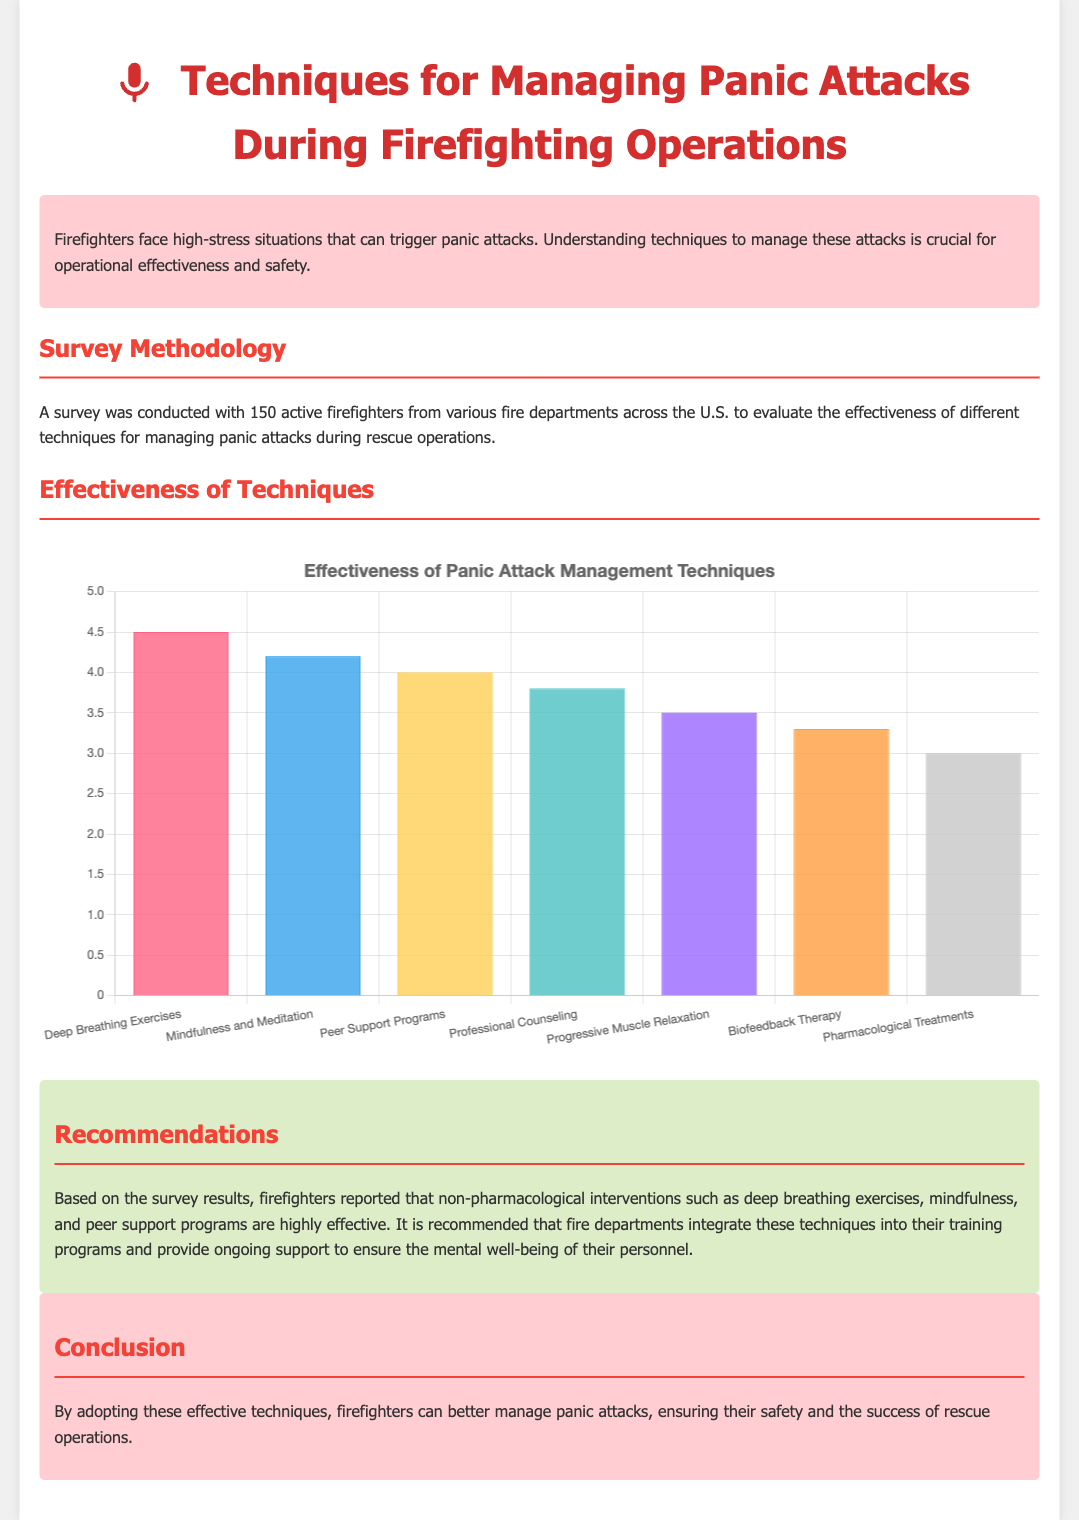What percentage of firefighters found deep breathing exercises effective? According to the survey data, deep breathing exercises received an effectiveness rating of 4.5 out of 5.
Answer: 4.5 Which technique received the lowest effectiveness rating? The technique with the lowest rating is pharmacological treatments, with a score of 3.0.
Answer: Pharmacological treatments What is the primary focus of the recommendations section? The recommendations section emphasizes the integration of non-pharmacological interventions into training programs for firefighters.
Answer: Non-pharmacological interventions How many firefighters participated in the survey? The total number of firefighters surveyed for the effectiveness of panic attack management techniques is 150.
Answer: 150 What type of graph is used to display the effectiveness of each technique? The effectiveness of the panic attack management techniques is displayed using a bar graph.
Answer: Bar graph 